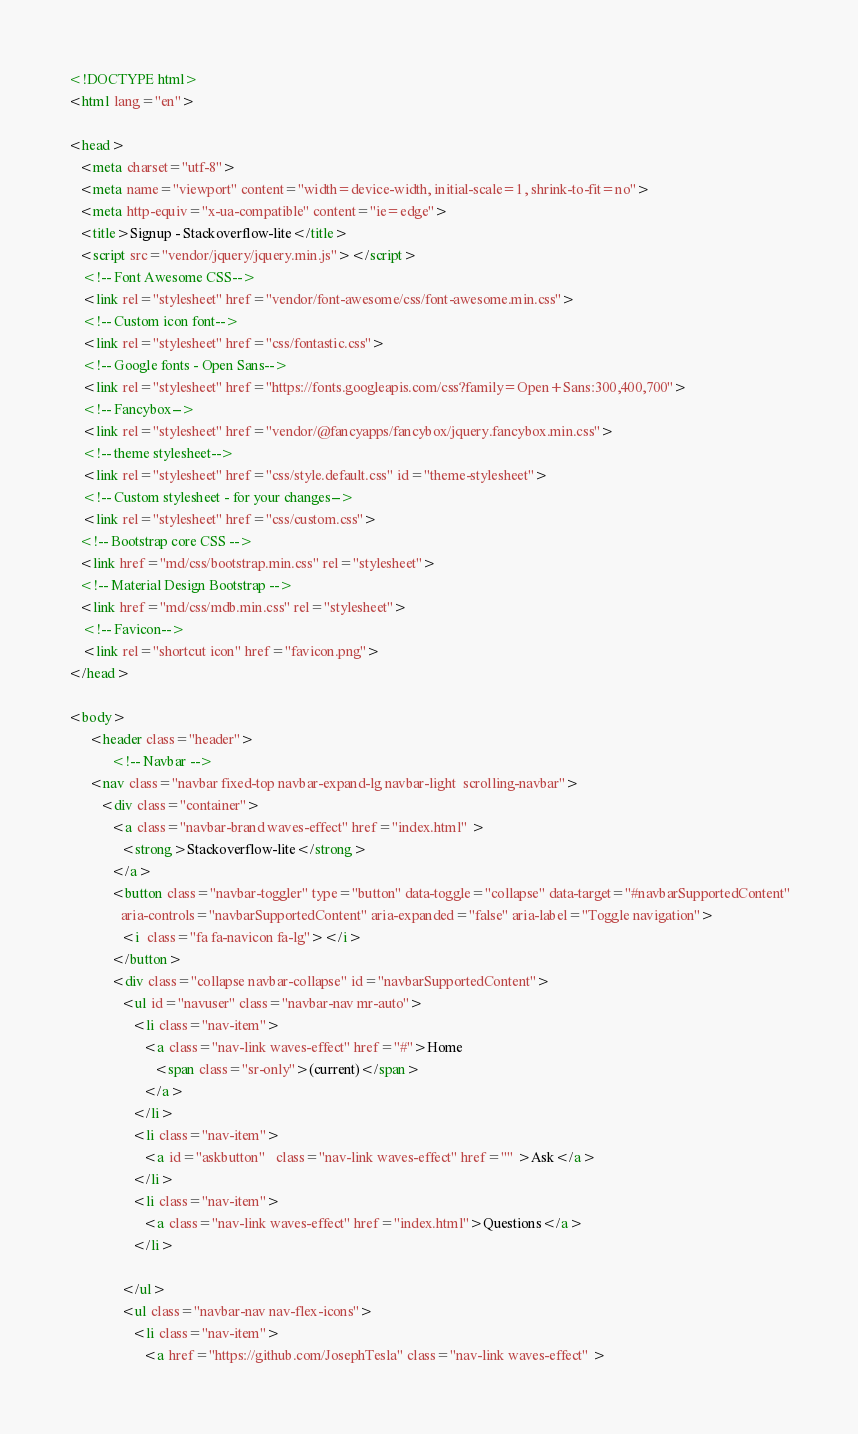Convert code to text. <code><loc_0><loc_0><loc_500><loc_500><_HTML_><!DOCTYPE html>
<html lang="en">

<head>
   <meta charset="utf-8">
   <meta name="viewport" content="width=device-width, initial-scale=1, shrink-to-fit=no">
   <meta http-equiv="x-ua-compatible" content="ie=edge">
   <title>Signup - Stackoverflow-lite</title>
   <script src="vendor/jquery/jquery.min.js"></script>
    <!-- Font Awesome CSS-->
    <link rel="stylesheet" href="vendor/font-awesome/css/font-awesome.min.css">
    <!-- Custom icon font-->
    <link rel="stylesheet" href="css/fontastic.css">
    <!-- Google fonts - Open Sans-->
    <link rel="stylesheet" href="https://fonts.googleapis.com/css?family=Open+Sans:300,400,700">
    <!-- Fancybox-->
    <link rel="stylesheet" href="vendor/@fancyapps/fancybox/jquery.fancybox.min.css">
    <!-- theme stylesheet-->
    <link rel="stylesheet" href="css/style.default.css" id="theme-stylesheet">
    <!-- Custom stylesheet - for your changes-->
    <link rel="stylesheet" href="css/custom.css">
   <!-- Bootstrap core CSS -->
   <link href="md/css/bootstrap.min.css" rel="stylesheet">
   <!-- Material Design Bootstrap -->
   <link href="md/css/mdb.min.css" rel="stylesheet">
    <!-- Favicon-->
    <link rel="shortcut icon" href="favicon.png">
</head>

<body>
      <header class="header">
            <!-- Navbar -->
      <nav class="navbar fixed-top navbar-expand-lg navbar-light  scrolling-navbar">
         <div class="container">
            <a class="navbar-brand waves-effect" href="index.html" >
               <strong>Stackoverflow-lite</strong>
            </a>
            <button class="navbar-toggler" type="button" data-toggle="collapse" data-target="#navbarSupportedContent"
               aria-controls="navbarSupportedContent" aria-expanded="false" aria-label="Toggle navigation">
               <i  class="fa fa-navicon fa-lg"></i>
            </button>
            <div class="collapse navbar-collapse" id="navbarSupportedContent">
               <ul id="navuser" class="navbar-nav mr-auto">
                  <li class="nav-item">
                     <a class="nav-link waves-effect" href="#">Home
                        <span class="sr-only">(current)</span>
                     </a>
                  </li>
                  <li class="nav-item">
                     <a id="askbutton"   class="nav-link waves-effect" href="" >Ask</a>
                  </li>
                  <li class="nav-item">
                     <a class="nav-link waves-effect" href="index.html">Questions</a>
                  </li>
                  
               </ul>
               <ul class="navbar-nav nav-flex-icons">
                  <li class="nav-item">
                     <a href="https://github.com/JosephTesla" class="nav-link waves-effect" ></code> 